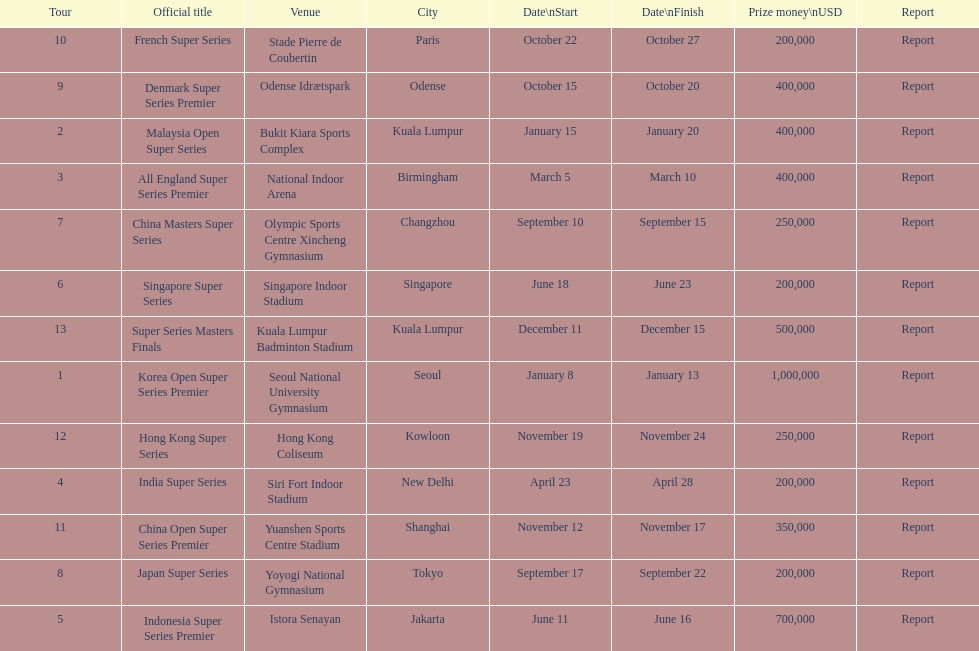How long did the japan super series take? 5 days. 